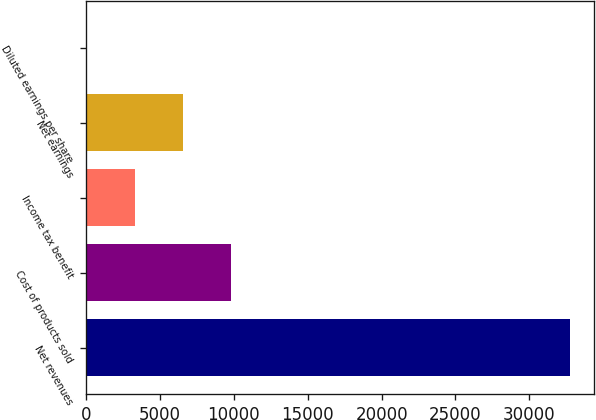Convert chart. <chart><loc_0><loc_0><loc_500><loc_500><bar_chart><fcel>Net revenues<fcel>Cost of products sold<fcel>Income tax benefit<fcel>Net earnings<fcel>Diluted earnings per share<nl><fcel>32753<fcel>9828.45<fcel>3278.59<fcel>6553.52<fcel>3.66<nl></chart> 